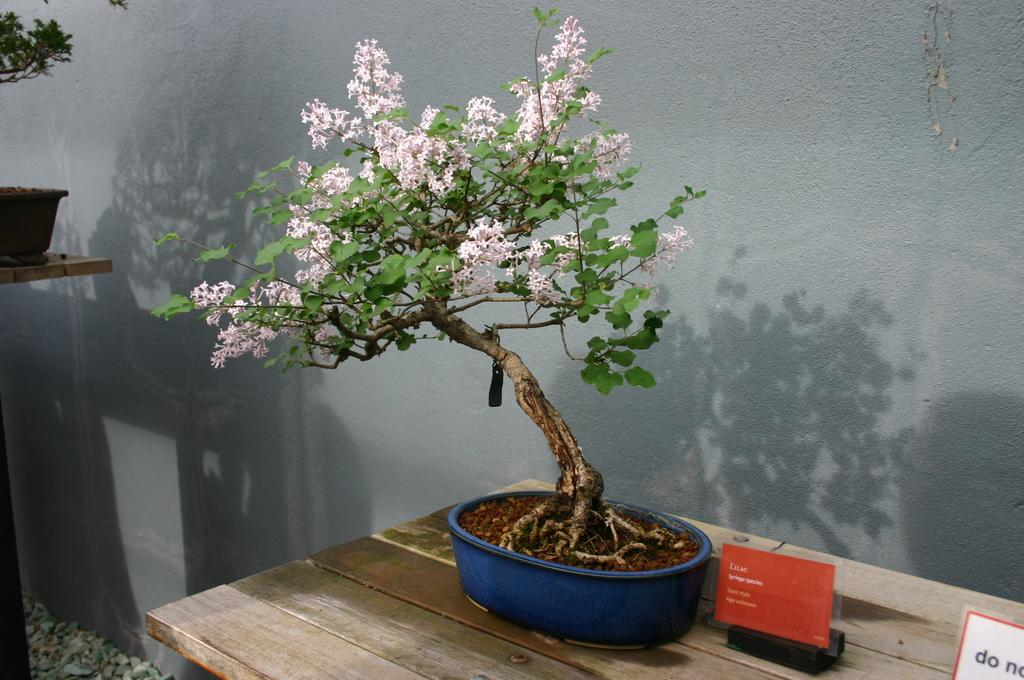What is on the tables in the image? There are plants and other things on the tables in the image. Can you describe the plants on the tables? The facts provided do not specify the type of plants on the tables. What can be seen in the background of the image? There is a wall in the background of the image. Are there any flowers visible in the image? Yes, flowers are present in the image. Where is the giraffe in the image? There is no giraffe present in the image. What type of brush is used to paint the wall in the image? The facts provided do not mention any painting or brushes in the image. 